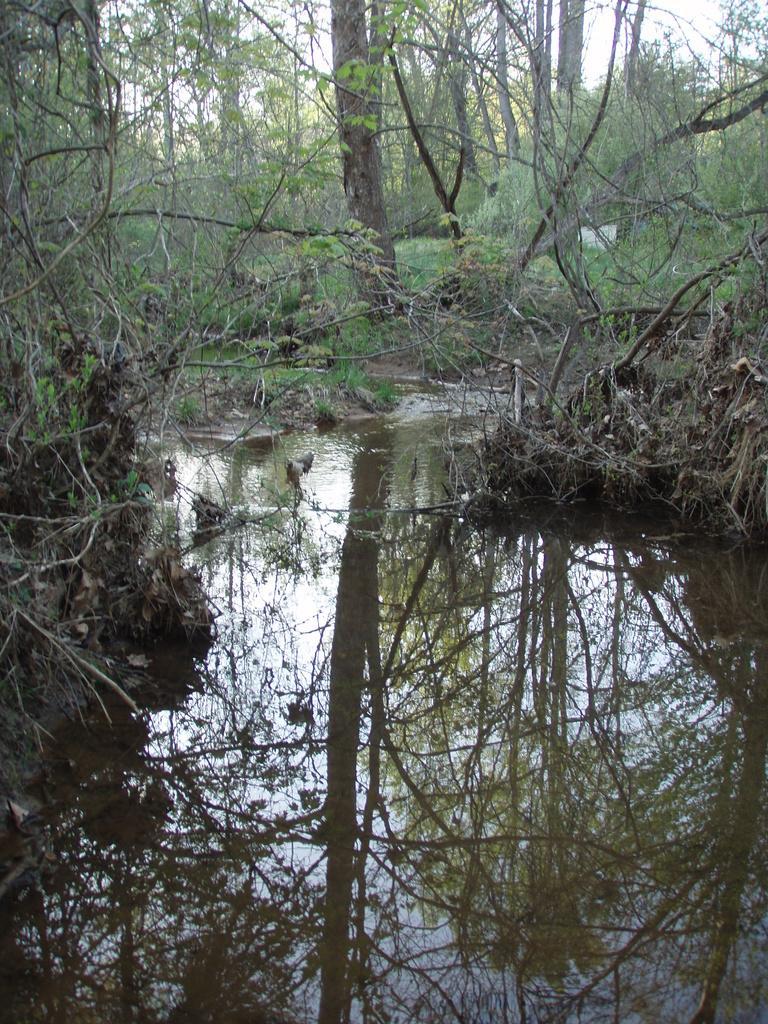Please provide a concise description of this image. In the foreground of the picture there is a water body. In the center of the picture there are trees and land. In the background there are trees. 